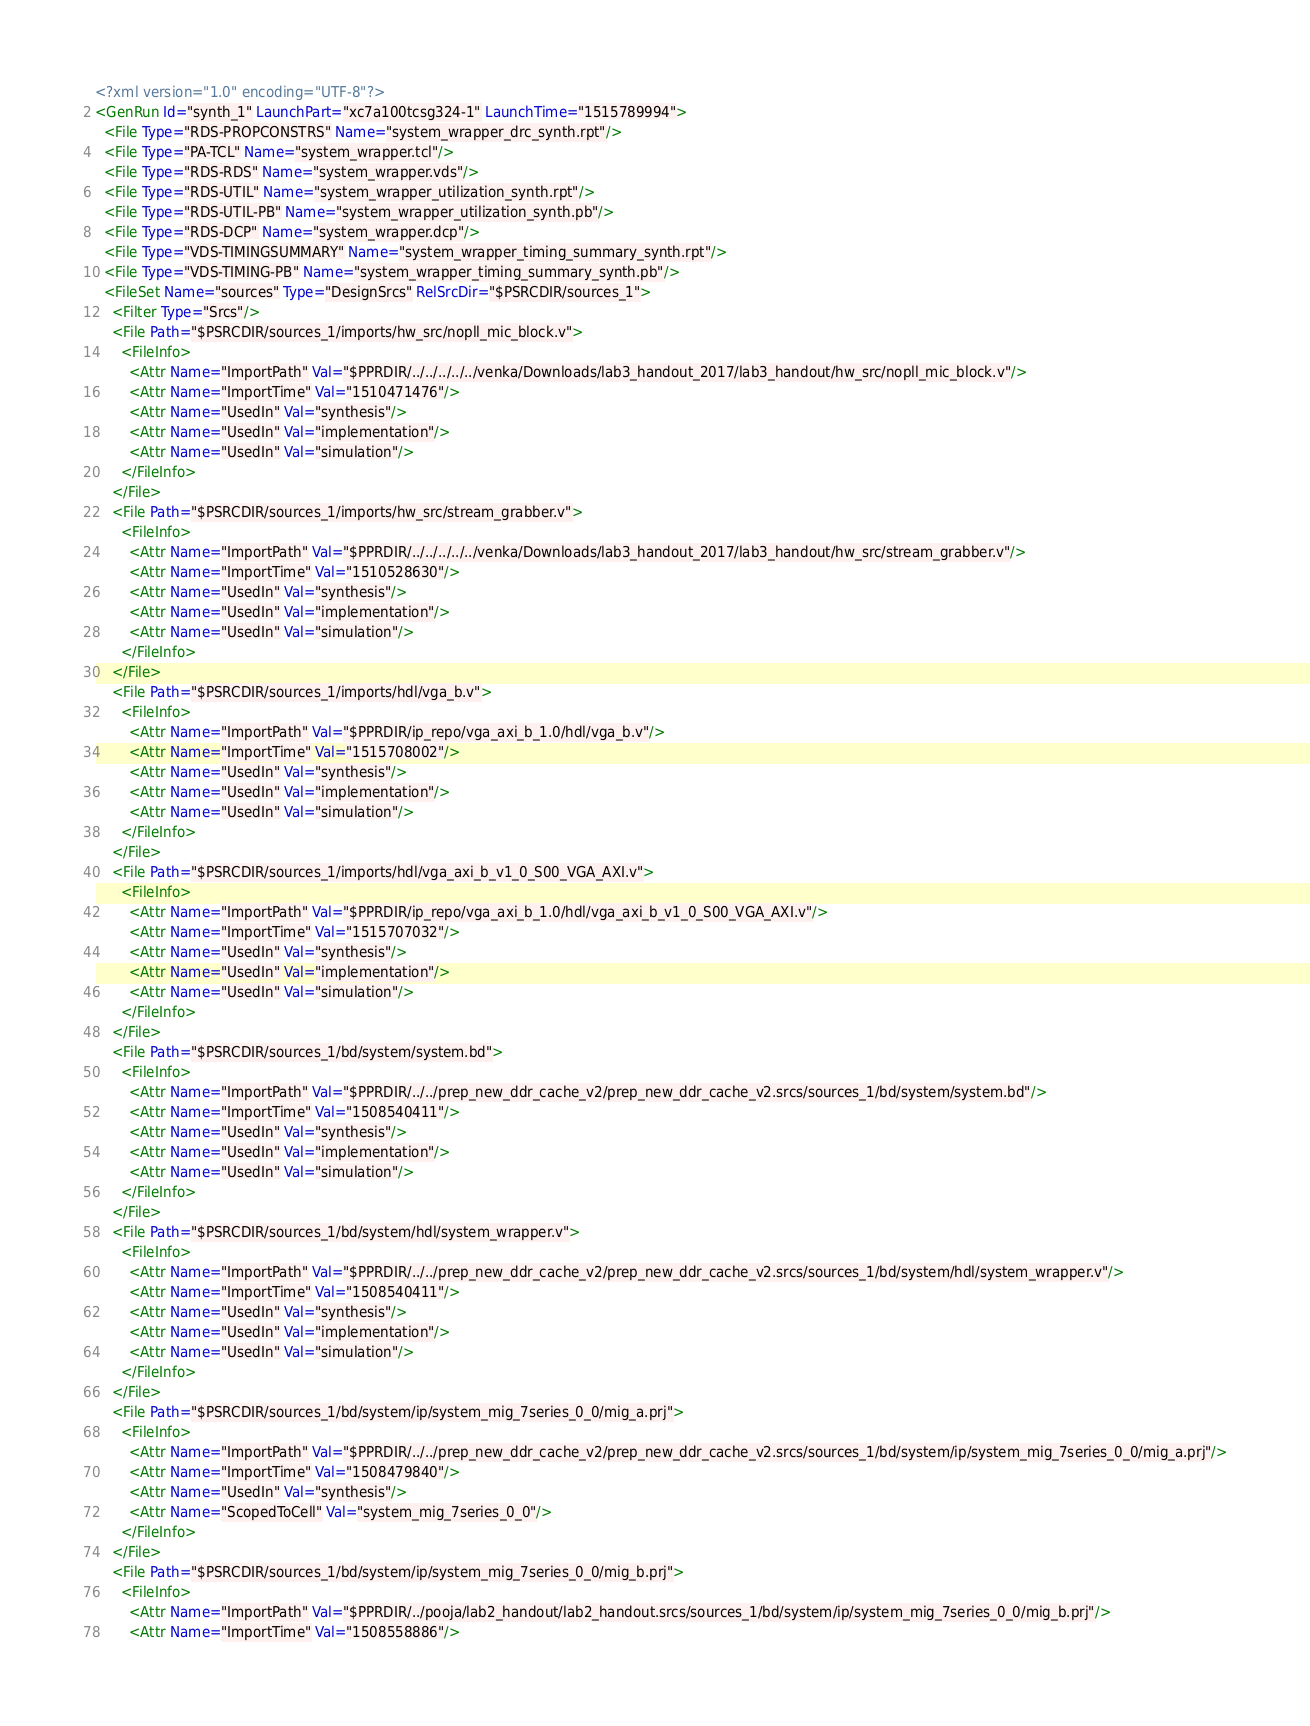Convert code to text. <code><loc_0><loc_0><loc_500><loc_500><_XML_><?xml version="1.0" encoding="UTF-8"?>
<GenRun Id="synth_1" LaunchPart="xc7a100tcsg324-1" LaunchTime="1515789994">
  <File Type="RDS-PROPCONSTRS" Name="system_wrapper_drc_synth.rpt"/>
  <File Type="PA-TCL" Name="system_wrapper.tcl"/>
  <File Type="RDS-RDS" Name="system_wrapper.vds"/>
  <File Type="RDS-UTIL" Name="system_wrapper_utilization_synth.rpt"/>
  <File Type="RDS-UTIL-PB" Name="system_wrapper_utilization_synth.pb"/>
  <File Type="RDS-DCP" Name="system_wrapper.dcp"/>
  <File Type="VDS-TIMINGSUMMARY" Name="system_wrapper_timing_summary_synth.rpt"/>
  <File Type="VDS-TIMING-PB" Name="system_wrapper_timing_summary_synth.pb"/>
  <FileSet Name="sources" Type="DesignSrcs" RelSrcDir="$PSRCDIR/sources_1">
    <Filter Type="Srcs"/>
    <File Path="$PSRCDIR/sources_1/imports/hw_src/nopll_mic_block.v">
      <FileInfo>
        <Attr Name="ImportPath" Val="$PPRDIR/../../../../../venka/Downloads/lab3_handout_2017/lab3_handout/hw_src/nopll_mic_block.v"/>
        <Attr Name="ImportTime" Val="1510471476"/>
        <Attr Name="UsedIn" Val="synthesis"/>
        <Attr Name="UsedIn" Val="implementation"/>
        <Attr Name="UsedIn" Val="simulation"/>
      </FileInfo>
    </File>
    <File Path="$PSRCDIR/sources_1/imports/hw_src/stream_grabber.v">
      <FileInfo>
        <Attr Name="ImportPath" Val="$PPRDIR/../../../../../venka/Downloads/lab3_handout_2017/lab3_handout/hw_src/stream_grabber.v"/>
        <Attr Name="ImportTime" Val="1510528630"/>
        <Attr Name="UsedIn" Val="synthesis"/>
        <Attr Name="UsedIn" Val="implementation"/>
        <Attr Name="UsedIn" Val="simulation"/>
      </FileInfo>
    </File>
    <File Path="$PSRCDIR/sources_1/imports/hdl/vga_b.v">
      <FileInfo>
        <Attr Name="ImportPath" Val="$PPRDIR/ip_repo/vga_axi_b_1.0/hdl/vga_b.v"/>
        <Attr Name="ImportTime" Val="1515708002"/>
        <Attr Name="UsedIn" Val="synthesis"/>
        <Attr Name="UsedIn" Val="implementation"/>
        <Attr Name="UsedIn" Val="simulation"/>
      </FileInfo>
    </File>
    <File Path="$PSRCDIR/sources_1/imports/hdl/vga_axi_b_v1_0_S00_VGA_AXI.v">
      <FileInfo>
        <Attr Name="ImportPath" Val="$PPRDIR/ip_repo/vga_axi_b_1.0/hdl/vga_axi_b_v1_0_S00_VGA_AXI.v"/>
        <Attr Name="ImportTime" Val="1515707032"/>
        <Attr Name="UsedIn" Val="synthesis"/>
        <Attr Name="UsedIn" Val="implementation"/>
        <Attr Name="UsedIn" Val="simulation"/>
      </FileInfo>
    </File>
    <File Path="$PSRCDIR/sources_1/bd/system/system.bd">
      <FileInfo>
        <Attr Name="ImportPath" Val="$PPRDIR/../../prep_new_ddr_cache_v2/prep_new_ddr_cache_v2.srcs/sources_1/bd/system/system.bd"/>
        <Attr Name="ImportTime" Val="1508540411"/>
        <Attr Name="UsedIn" Val="synthesis"/>
        <Attr Name="UsedIn" Val="implementation"/>
        <Attr Name="UsedIn" Val="simulation"/>
      </FileInfo>
    </File>
    <File Path="$PSRCDIR/sources_1/bd/system/hdl/system_wrapper.v">
      <FileInfo>
        <Attr Name="ImportPath" Val="$PPRDIR/../../prep_new_ddr_cache_v2/prep_new_ddr_cache_v2.srcs/sources_1/bd/system/hdl/system_wrapper.v"/>
        <Attr Name="ImportTime" Val="1508540411"/>
        <Attr Name="UsedIn" Val="synthesis"/>
        <Attr Name="UsedIn" Val="implementation"/>
        <Attr Name="UsedIn" Val="simulation"/>
      </FileInfo>
    </File>
    <File Path="$PSRCDIR/sources_1/bd/system/ip/system_mig_7series_0_0/mig_a.prj">
      <FileInfo>
        <Attr Name="ImportPath" Val="$PPRDIR/../../prep_new_ddr_cache_v2/prep_new_ddr_cache_v2.srcs/sources_1/bd/system/ip/system_mig_7series_0_0/mig_a.prj"/>
        <Attr Name="ImportTime" Val="1508479840"/>
        <Attr Name="UsedIn" Val="synthesis"/>
        <Attr Name="ScopedToCell" Val="system_mig_7series_0_0"/>
      </FileInfo>
    </File>
    <File Path="$PSRCDIR/sources_1/bd/system/ip/system_mig_7series_0_0/mig_b.prj">
      <FileInfo>
        <Attr Name="ImportPath" Val="$PPRDIR/../pooja/lab2_handout/lab2_handout.srcs/sources_1/bd/system/ip/system_mig_7series_0_0/mig_b.prj"/>
        <Attr Name="ImportTime" Val="1508558886"/></code> 